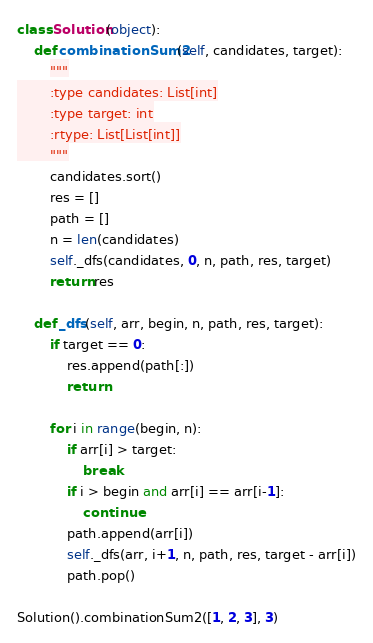Convert code to text. <code><loc_0><loc_0><loc_500><loc_500><_Python_>



class Solution(object):
    def combinationSum2(self, candidates, target):
        """
        :type candidates: List[int]
        :type target: int
        :rtype: List[List[int]]
        """
        candidates.sort()
        res = []
        path = []
        n = len(candidates)
        self._dfs(candidates, 0, n, path, res, target)
        return res

    def _dfs(self, arr, begin, n, path, res, target):
        if target == 0:
            res.append(path[:])
            return

        for i in range(begin, n):
            if arr[i] > target:
                break
            if i > begin and arr[i] == arr[i-1]:
                continue
            path.append(arr[i])
            self._dfs(arr, i+1, n, path, res, target - arr[i])
            path.pop()

Solution().combinationSum2([1, 2, 3], 3)
</code> 